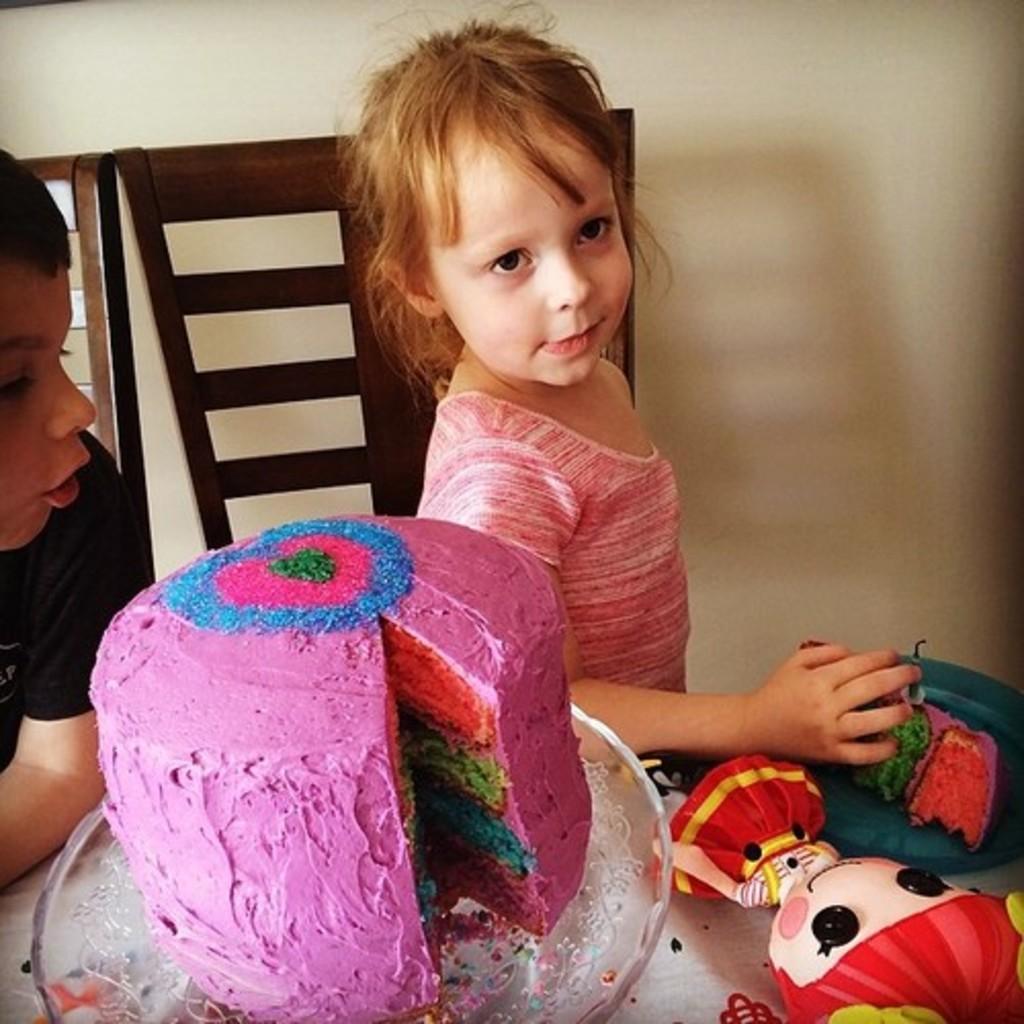In one or two sentences, can you explain what this image depicts? In the foreground of the picture there are toys, cake and other objects. In the center of the picture there are chairs and two kids. At the top it is wall painted white. 